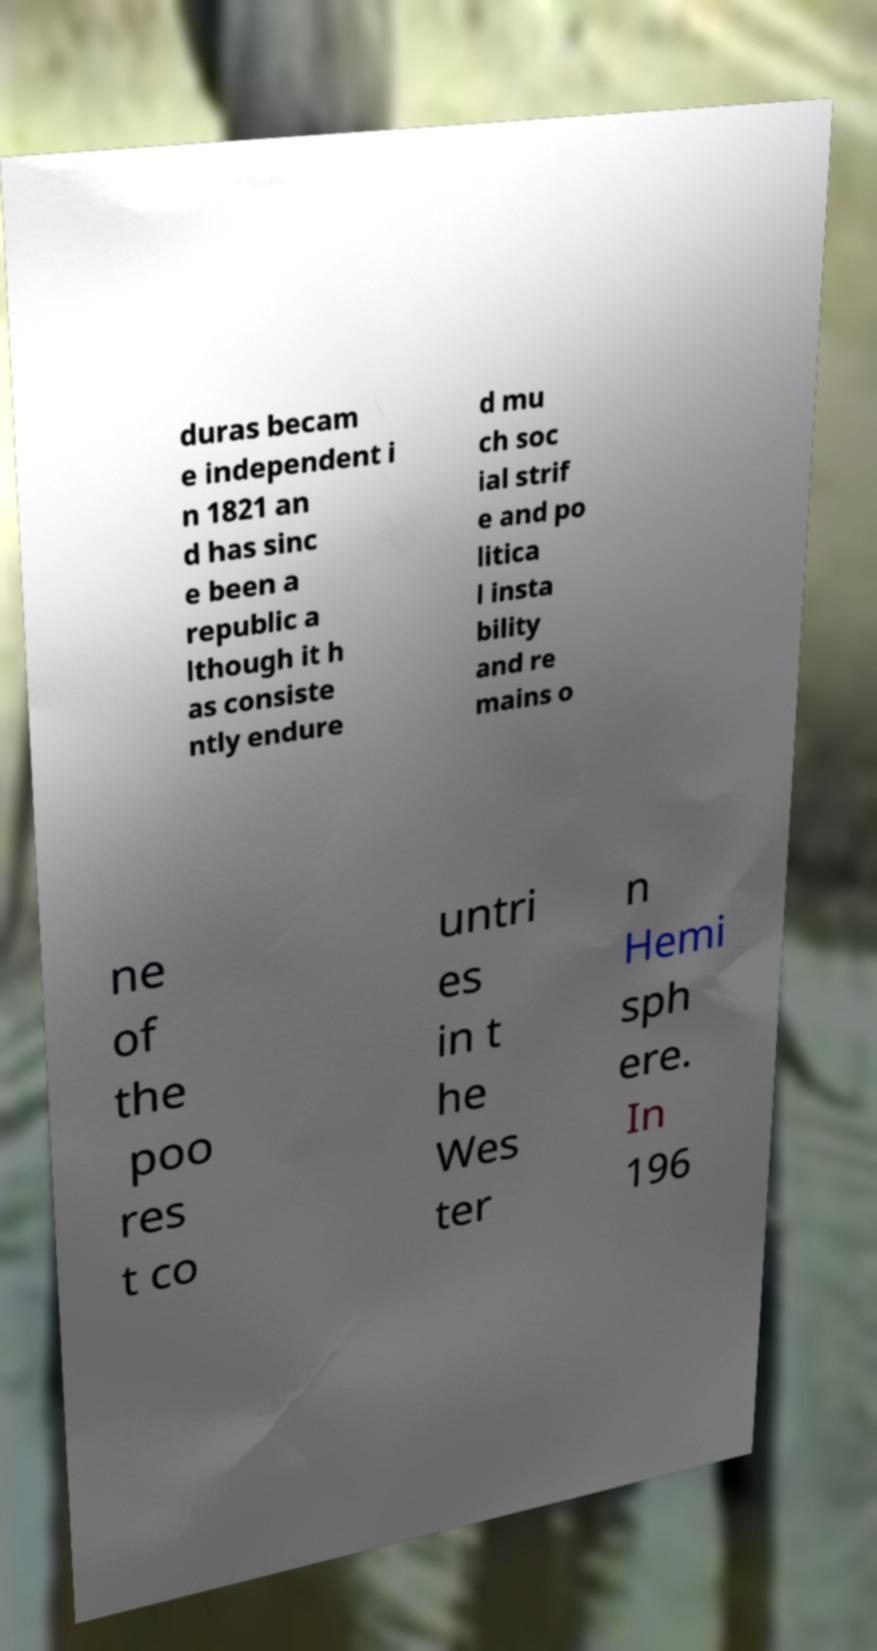Please read and relay the text visible in this image. What does it say? duras becam e independent i n 1821 an d has sinc e been a republic a lthough it h as consiste ntly endure d mu ch soc ial strif e and po litica l insta bility and re mains o ne of the poo res t co untri es in t he Wes ter n Hemi sph ere. In 196 